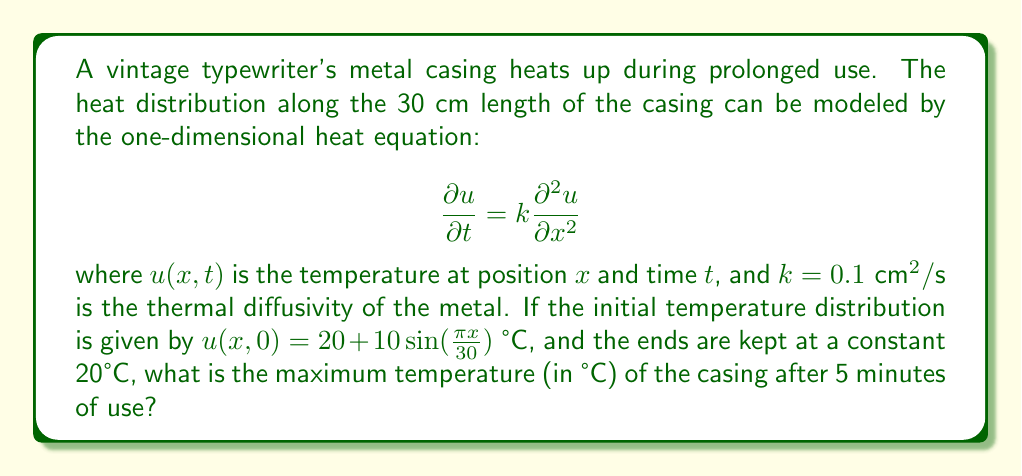Solve this math problem. To solve this problem, we need to use the separation of variables method for the heat equation:

1) The general solution for the heat equation with the given boundary conditions is:

   $$ u(x,t) = 20 + \sum_{n=1}^{\infty} B_n \sin(\frac{n\pi x}{30}) e^{-k(\frac{n\pi}{30})^2t} $$

2) The initial condition is $u(x,0) = 20 + 10\sin(\frac{\pi x}{30})$, so we only have one term in the series with $n=1$ and $B_1 = 10$.

3) Therefore, our specific solution is:

   $$ u(x,t) = 20 + 10\sin(\frac{\pi x}{30}) e^{-k(\frac{\pi}{30})^2t} $$

4) The maximum temperature will occur at $x = 15$ cm (the midpoint) at $t = 5$ minutes = 300 seconds.

5) Substituting these values:

   $$ u(15,300) = 20 + 10\sin(\frac{\pi 15}{30}) e^{-0.1(\frac{\pi}{30})^2 300} $$

6) Simplify:
   $$ u(15,300) = 20 + 10 \cdot 1 \cdot e^{-0.1(\frac{\pi}{30})^2 300} $$
   $$ = 20 + 10e^{-0.1(\frac{\pi^2}{900}) 300} $$
   $$ = 20 + 10e^{-\frac{\pi^2}{30}} $$

7) Calculate the result:
   $$ \approx 20 + 10 \cdot 0.7222 = 27.222 \text{ °C} $$
Answer: 27.22 °C 